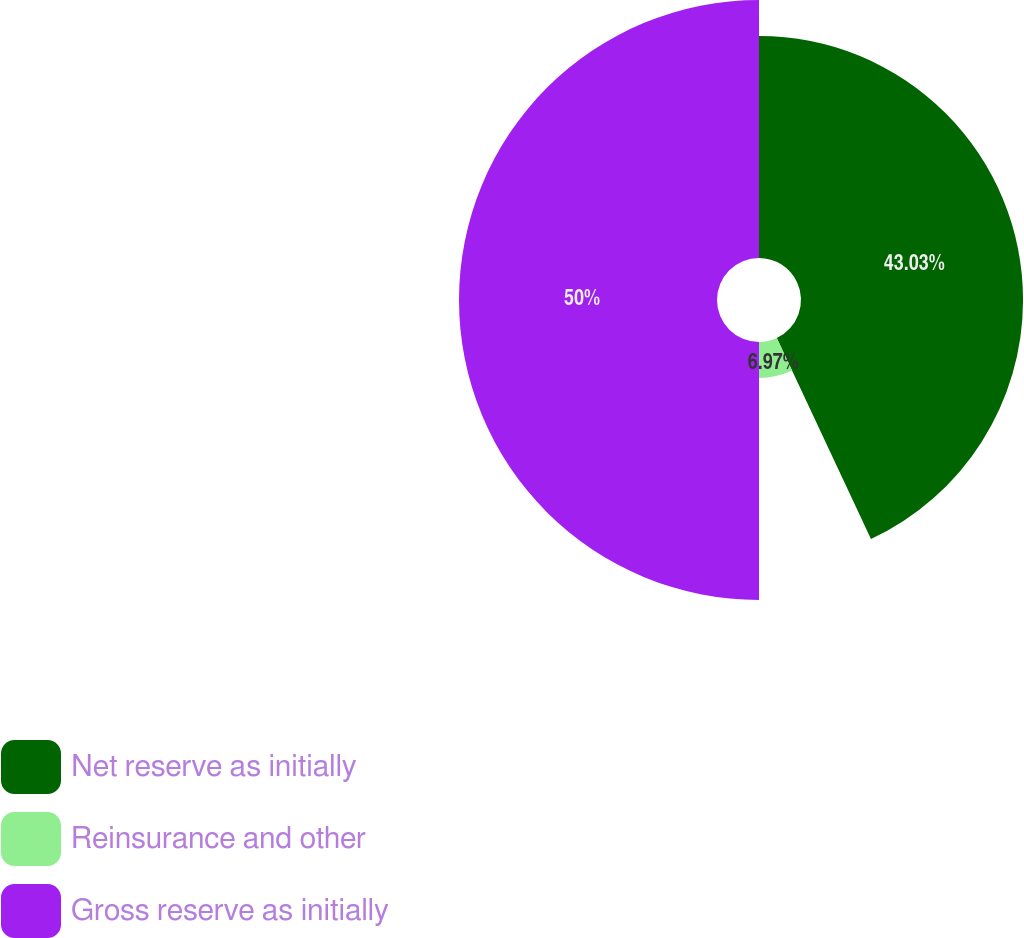Convert chart to OTSL. <chart><loc_0><loc_0><loc_500><loc_500><pie_chart><fcel>Net reserve as initially<fcel>Reinsurance and other<fcel>Gross reserve as initially<nl><fcel>43.03%<fcel>6.97%<fcel>50.0%<nl></chart> 